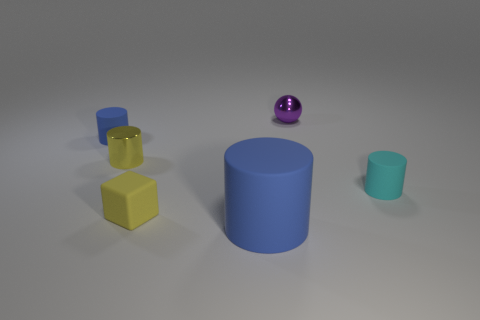The other tiny metallic thing that is the same shape as the cyan object is what color?
Keep it short and to the point. Yellow. There is a cylinder that is to the left of the small yellow rubber block and in front of the tiny blue rubber object; what is its size?
Offer a terse response. Small. There is a small rubber cylinder that is on the left side of the matte cylinder that is to the right of the purple sphere; how many tiny cubes are to the right of it?
Ensure brevity in your answer.  1. How many large things are either matte objects or blue matte cylinders?
Provide a succinct answer. 1. Does the blue object that is in front of the tiny yellow rubber block have the same material as the cube?
Provide a succinct answer. Yes. What is the material of the cylinder that is right of the blue matte thing that is to the right of the tiny blue rubber object that is behind the large blue cylinder?
Your response must be concise. Rubber. Is there any other thing that has the same size as the shiny ball?
Offer a terse response. Yes. What number of rubber objects are small green objects or tiny cylinders?
Offer a very short reply. 2. Are there any tiny matte cylinders?
Your answer should be very brief. Yes. What color is the small metal sphere that is on the left side of the tiny cyan thing in front of the small purple ball?
Make the answer very short. Purple. 